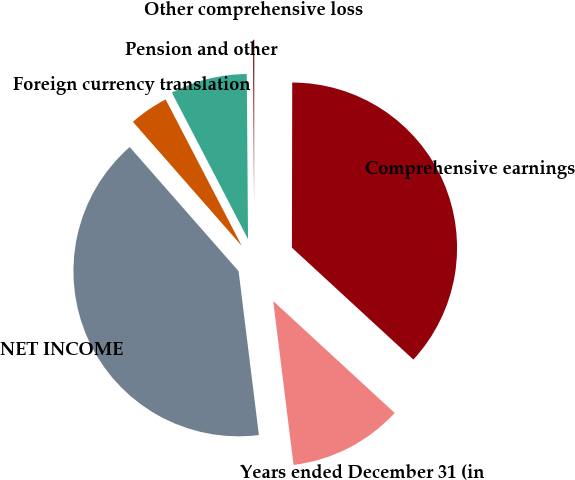Convert chart to OTSL. <chart><loc_0><loc_0><loc_500><loc_500><pie_chart><fcel>Years ended December 31 (in<fcel>NET INCOME<fcel>Foreign currency translation<fcel>Pension and other<fcel>Other comprehensive loss<fcel>Comprehensive earnings<nl><fcel>11.19%<fcel>40.5%<fcel>3.83%<fcel>7.51%<fcel>0.15%<fcel>36.82%<nl></chart> 